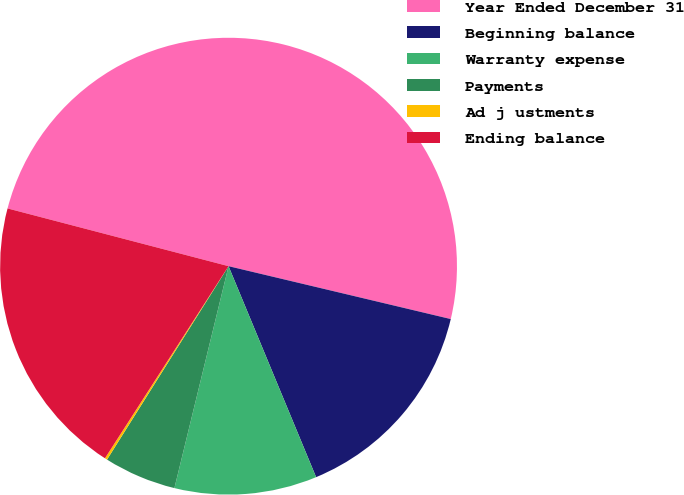<chart> <loc_0><loc_0><loc_500><loc_500><pie_chart><fcel>Year Ended December 31<fcel>Beginning balance<fcel>Warranty expense<fcel>Payments<fcel>Ad j ustments<fcel>Ending balance<nl><fcel>49.65%<fcel>15.02%<fcel>10.07%<fcel>5.12%<fcel>0.17%<fcel>19.97%<nl></chart> 